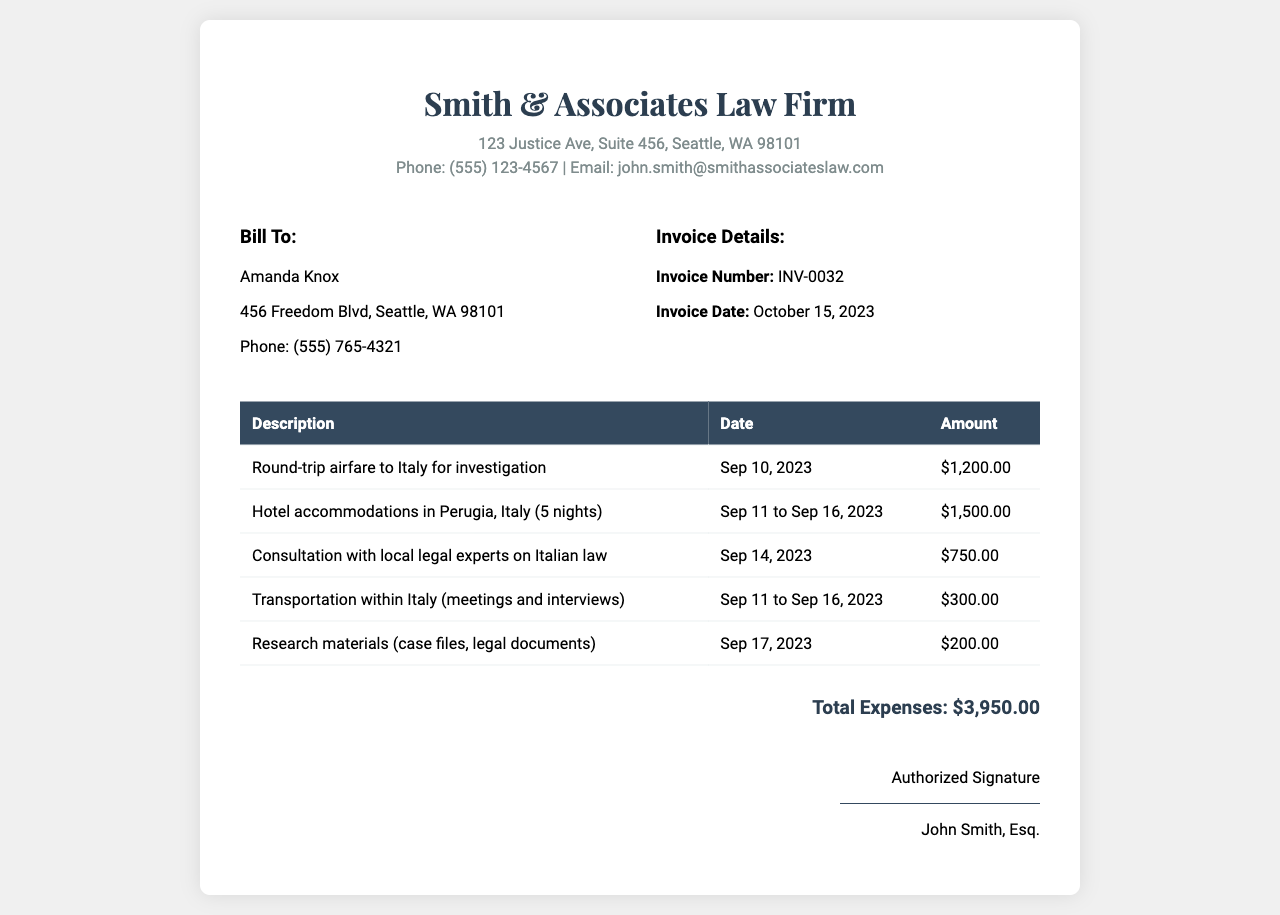What is the invoice number? The invoice number is specified in the document as a unique identifier for the invoice.
Answer: INV-0032 Who is the bill to? The "Bill To" section identifies the recipient of the invoice, which is an individual or organization.
Answer: Amanda Knox What is the total amount of expenses? The total expenses are calculated by summing all the itemized charges listed in the document.
Answer: $3,950.00 What is the date of the invoice? The invoice date indicates when the invoice was generated and is stated in clear terms.
Answer: October 15, 2023 How many nights was the hotel accommodation? The invoice details the duration of the hotel stay in terms of the number of nights.
Answer: 5 nights Which date was the consultation with local legal experts? The document lists the specific date on which the consultation occurred, conveying important scheduling information.
Answer: Sep 14, 2023 What type of expenses are itemized in the invoice? The expenses are listed in a table format and include specific service categories related to the investigation.
Answer: Travel, lodging, consultation fees What was the cost of round-trip airfare to Italy? The airfare cost is explicitly mentioned in the itemized list, providing straightforward financial information.
Answer: $1,200.00 Who authorized the invoice? The signature section indicates who has authorized the invoice, providing accountability for the charges.
Answer: John Smith, Esq 